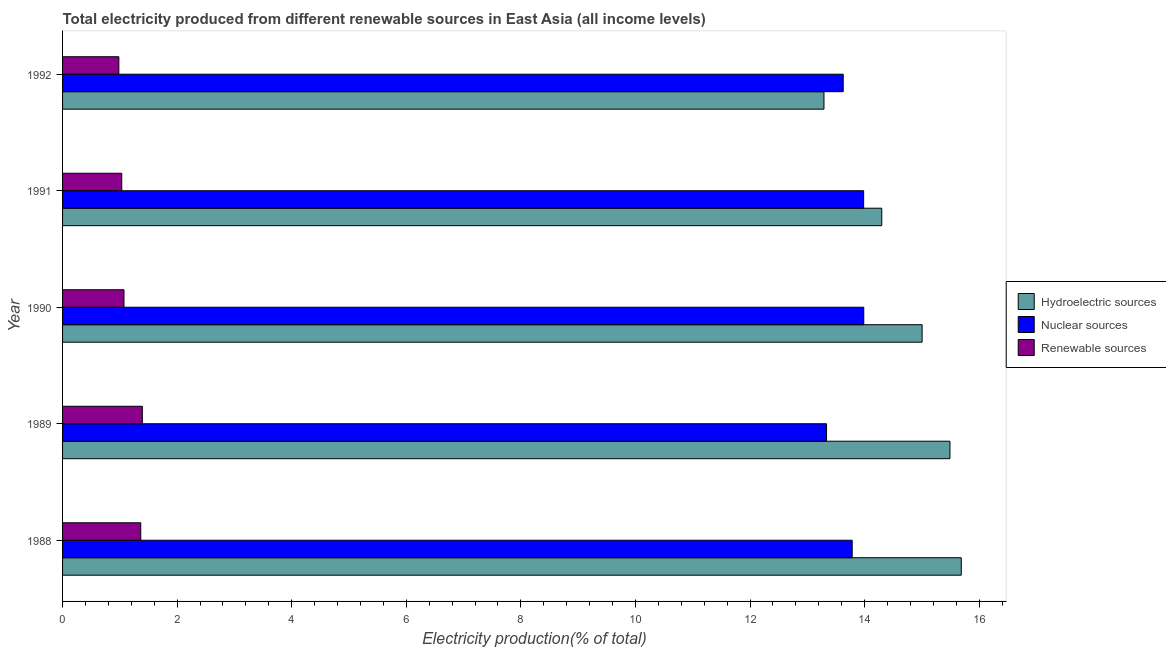How many groups of bars are there?
Make the answer very short. 5. Are the number of bars on each tick of the Y-axis equal?
Provide a short and direct response. Yes. What is the label of the 1st group of bars from the top?
Offer a terse response. 1992. In how many cases, is the number of bars for a given year not equal to the number of legend labels?
Your answer should be very brief. 0. What is the percentage of electricity produced by hydroelectric sources in 1992?
Your response must be concise. 13.29. Across all years, what is the maximum percentage of electricity produced by renewable sources?
Your response must be concise. 1.39. Across all years, what is the minimum percentage of electricity produced by nuclear sources?
Your answer should be very brief. 13.34. In which year was the percentage of electricity produced by nuclear sources maximum?
Make the answer very short. 1990. What is the total percentage of electricity produced by renewable sources in the graph?
Keep it short and to the point. 5.84. What is the difference between the percentage of electricity produced by renewable sources in 1989 and that in 1990?
Your answer should be compact. 0.32. What is the difference between the percentage of electricity produced by renewable sources in 1991 and the percentage of electricity produced by hydroelectric sources in 1989?
Your answer should be compact. -14.46. What is the average percentage of electricity produced by renewable sources per year?
Keep it short and to the point. 1.17. In the year 1992, what is the difference between the percentage of electricity produced by nuclear sources and percentage of electricity produced by hydroelectric sources?
Make the answer very short. 0.34. In how many years, is the percentage of electricity produced by nuclear sources greater than 6.4 %?
Keep it short and to the point. 5. What is the ratio of the percentage of electricity produced by hydroelectric sources in 1988 to that in 1991?
Keep it short and to the point. 1.1. Is the difference between the percentage of electricity produced by renewable sources in 1988 and 1992 greater than the difference between the percentage of electricity produced by hydroelectric sources in 1988 and 1992?
Provide a succinct answer. No. What is the difference between the highest and the second highest percentage of electricity produced by nuclear sources?
Ensure brevity in your answer.  0. What is the difference between the highest and the lowest percentage of electricity produced by hydroelectric sources?
Ensure brevity in your answer.  2.4. Is the sum of the percentage of electricity produced by renewable sources in 1989 and 1991 greater than the maximum percentage of electricity produced by hydroelectric sources across all years?
Ensure brevity in your answer.  No. What does the 1st bar from the top in 1988 represents?
Give a very brief answer. Renewable sources. What does the 2nd bar from the bottom in 1990 represents?
Ensure brevity in your answer.  Nuclear sources. Is it the case that in every year, the sum of the percentage of electricity produced by hydroelectric sources and percentage of electricity produced by nuclear sources is greater than the percentage of electricity produced by renewable sources?
Provide a succinct answer. Yes. How many bars are there?
Your response must be concise. 15. How many years are there in the graph?
Keep it short and to the point. 5. Are the values on the major ticks of X-axis written in scientific E-notation?
Provide a short and direct response. No. Where does the legend appear in the graph?
Your answer should be very brief. Center right. How are the legend labels stacked?
Your answer should be compact. Vertical. What is the title of the graph?
Your answer should be very brief. Total electricity produced from different renewable sources in East Asia (all income levels). What is the label or title of the X-axis?
Make the answer very short. Electricity production(% of total). What is the label or title of the Y-axis?
Your response must be concise. Year. What is the Electricity production(% of total) of Hydroelectric sources in 1988?
Offer a terse response. 15.69. What is the Electricity production(% of total) in Nuclear sources in 1988?
Give a very brief answer. 13.78. What is the Electricity production(% of total) in Renewable sources in 1988?
Your response must be concise. 1.36. What is the Electricity production(% of total) of Hydroelectric sources in 1989?
Make the answer very short. 15.49. What is the Electricity production(% of total) of Nuclear sources in 1989?
Provide a succinct answer. 13.34. What is the Electricity production(% of total) of Renewable sources in 1989?
Provide a short and direct response. 1.39. What is the Electricity production(% of total) of Hydroelectric sources in 1990?
Make the answer very short. 15. What is the Electricity production(% of total) of Nuclear sources in 1990?
Your response must be concise. 13.99. What is the Electricity production(% of total) in Renewable sources in 1990?
Your answer should be compact. 1.07. What is the Electricity production(% of total) in Hydroelectric sources in 1991?
Make the answer very short. 14.3. What is the Electricity production(% of total) in Nuclear sources in 1991?
Your response must be concise. 13.98. What is the Electricity production(% of total) of Renewable sources in 1991?
Provide a succinct answer. 1.03. What is the Electricity production(% of total) of Hydroelectric sources in 1992?
Your response must be concise. 13.29. What is the Electricity production(% of total) in Nuclear sources in 1992?
Offer a terse response. 13.63. What is the Electricity production(% of total) of Renewable sources in 1992?
Your answer should be very brief. 0.98. Across all years, what is the maximum Electricity production(% of total) of Hydroelectric sources?
Your response must be concise. 15.69. Across all years, what is the maximum Electricity production(% of total) in Nuclear sources?
Offer a very short reply. 13.99. Across all years, what is the maximum Electricity production(% of total) of Renewable sources?
Your response must be concise. 1.39. Across all years, what is the minimum Electricity production(% of total) of Hydroelectric sources?
Keep it short and to the point. 13.29. Across all years, what is the minimum Electricity production(% of total) in Nuclear sources?
Provide a short and direct response. 13.34. Across all years, what is the minimum Electricity production(% of total) in Renewable sources?
Provide a short and direct response. 0.98. What is the total Electricity production(% of total) of Hydroelectric sources in the graph?
Give a very brief answer. 73.77. What is the total Electricity production(% of total) in Nuclear sources in the graph?
Give a very brief answer. 68.71. What is the total Electricity production(% of total) in Renewable sources in the graph?
Your response must be concise. 5.84. What is the difference between the Electricity production(% of total) of Hydroelectric sources in 1988 and that in 1989?
Give a very brief answer. 0.2. What is the difference between the Electricity production(% of total) in Nuclear sources in 1988 and that in 1989?
Offer a terse response. 0.45. What is the difference between the Electricity production(% of total) of Renewable sources in 1988 and that in 1989?
Make the answer very short. -0.03. What is the difference between the Electricity production(% of total) of Hydroelectric sources in 1988 and that in 1990?
Your answer should be compact. 0.68. What is the difference between the Electricity production(% of total) in Nuclear sources in 1988 and that in 1990?
Offer a very short reply. -0.2. What is the difference between the Electricity production(% of total) of Renewable sources in 1988 and that in 1990?
Your answer should be very brief. 0.29. What is the difference between the Electricity production(% of total) in Hydroelectric sources in 1988 and that in 1991?
Make the answer very short. 1.39. What is the difference between the Electricity production(% of total) of Nuclear sources in 1988 and that in 1991?
Offer a very short reply. -0.2. What is the difference between the Electricity production(% of total) of Renewable sources in 1988 and that in 1991?
Your answer should be very brief. 0.33. What is the difference between the Electricity production(% of total) of Hydroelectric sources in 1988 and that in 1992?
Ensure brevity in your answer.  2.4. What is the difference between the Electricity production(% of total) of Nuclear sources in 1988 and that in 1992?
Provide a succinct answer. 0.16. What is the difference between the Electricity production(% of total) of Renewable sources in 1988 and that in 1992?
Provide a short and direct response. 0.38. What is the difference between the Electricity production(% of total) of Hydroelectric sources in 1989 and that in 1990?
Ensure brevity in your answer.  0.49. What is the difference between the Electricity production(% of total) in Nuclear sources in 1989 and that in 1990?
Give a very brief answer. -0.65. What is the difference between the Electricity production(% of total) of Renewable sources in 1989 and that in 1990?
Give a very brief answer. 0.32. What is the difference between the Electricity production(% of total) in Hydroelectric sources in 1989 and that in 1991?
Offer a very short reply. 1.19. What is the difference between the Electricity production(% of total) in Nuclear sources in 1989 and that in 1991?
Make the answer very short. -0.65. What is the difference between the Electricity production(% of total) of Renewable sources in 1989 and that in 1991?
Your answer should be very brief. 0.36. What is the difference between the Electricity production(% of total) of Hydroelectric sources in 1989 and that in 1992?
Ensure brevity in your answer.  2.2. What is the difference between the Electricity production(% of total) of Nuclear sources in 1989 and that in 1992?
Your answer should be compact. -0.29. What is the difference between the Electricity production(% of total) of Renewable sources in 1989 and that in 1992?
Provide a short and direct response. 0.41. What is the difference between the Electricity production(% of total) in Hydroelectric sources in 1990 and that in 1991?
Offer a very short reply. 0.7. What is the difference between the Electricity production(% of total) in Nuclear sources in 1990 and that in 1991?
Keep it short and to the point. 0. What is the difference between the Electricity production(% of total) of Renewable sources in 1990 and that in 1991?
Provide a succinct answer. 0.04. What is the difference between the Electricity production(% of total) in Hydroelectric sources in 1990 and that in 1992?
Give a very brief answer. 1.71. What is the difference between the Electricity production(% of total) in Nuclear sources in 1990 and that in 1992?
Ensure brevity in your answer.  0.36. What is the difference between the Electricity production(% of total) of Renewable sources in 1990 and that in 1992?
Give a very brief answer. 0.09. What is the difference between the Electricity production(% of total) of Hydroelectric sources in 1991 and that in 1992?
Offer a terse response. 1.01. What is the difference between the Electricity production(% of total) of Nuclear sources in 1991 and that in 1992?
Your answer should be compact. 0.36. What is the difference between the Electricity production(% of total) of Renewable sources in 1991 and that in 1992?
Keep it short and to the point. 0.05. What is the difference between the Electricity production(% of total) in Hydroelectric sources in 1988 and the Electricity production(% of total) in Nuclear sources in 1989?
Make the answer very short. 2.35. What is the difference between the Electricity production(% of total) in Hydroelectric sources in 1988 and the Electricity production(% of total) in Renewable sources in 1989?
Your answer should be compact. 14.29. What is the difference between the Electricity production(% of total) in Nuclear sources in 1988 and the Electricity production(% of total) in Renewable sources in 1989?
Provide a succinct answer. 12.39. What is the difference between the Electricity production(% of total) in Hydroelectric sources in 1988 and the Electricity production(% of total) in Nuclear sources in 1990?
Make the answer very short. 1.7. What is the difference between the Electricity production(% of total) of Hydroelectric sources in 1988 and the Electricity production(% of total) of Renewable sources in 1990?
Your answer should be compact. 14.61. What is the difference between the Electricity production(% of total) of Nuclear sources in 1988 and the Electricity production(% of total) of Renewable sources in 1990?
Offer a terse response. 12.71. What is the difference between the Electricity production(% of total) in Hydroelectric sources in 1988 and the Electricity production(% of total) in Nuclear sources in 1991?
Your answer should be very brief. 1.7. What is the difference between the Electricity production(% of total) of Hydroelectric sources in 1988 and the Electricity production(% of total) of Renewable sources in 1991?
Make the answer very short. 14.65. What is the difference between the Electricity production(% of total) of Nuclear sources in 1988 and the Electricity production(% of total) of Renewable sources in 1991?
Ensure brevity in your answer.  12.75. What is the difference between the Electricity production(% of total) in Hydroelectric sources in 1988 and the Electricity production(% of total) in Nuclear sources in 1992?
Keep it short and to the point. 2.06. What is the difference between the Electricity production(% of total) of Hydroelectric sources in 1988 and the Electricity production(% of total) of Renewable sources in 1992?
Keep it short and to the point. 14.7. What is the difference between the Electricity production(% of total) of Nuclear sources in 1988 and the Electricity production(% of total) of Renewable sources in 1992?
Offer a terse response. 12.8. What is the difference between the Electricity production(% of total) in Hydroelectric sources in 1989 and the Electricity production(% of total) in Nuclear sources in 1990?
Ensure brevity in your answer.  1.5. What is the difference between the Electricity production(% of total) in Hydroelectric sources in 1989 and the Electricity production(% of total) in Renewable sources in 1990?
Keep it short and to the point. 14.42. What is the difference between the Electricity production(% of total) of Nuclear sources in 1989 and the Electricity production(% of total) of Renewable sources in 1990?
Your answer should be compact. 12.26. What is the difference between the Electricity production(% of total) in Hydroelectric sources in 1989 and the Electricity production(% of total) in Nuclear sources in 1991?
Your response must be concise. 1.51. What is the difference between the Electricity production(% of total) in Hydroelectric sources in 1989 and the Electricity production(% of total) in Renewable sources in 1991?
Provide a succinct answer. 14.46. What is the difference between the Electricity production(% of total) of Nuclear sources in 1989 and the Electricity production(% of total) of Renewable sources in 1991?
Keep it short and to the point. 12.3. What is the difference between the Electricity production(% of total) of Hydroelectric sources in 1989 and the Electricity production(% of total) of Nuclear sources in 1992?
Your response must be concise. 1.86. What is the difference between the Electricity production(% of total) of Hydroelectric sources in 1989 and the Electricity production(% of total) of Renewable sources in 1992?
Ensure brevity in your answer.  14.51. What is the difference between the Electricity production(% of total) in Nuclear sources in 1989 and the Electricity production(% of total) in Renewable sources in 1992?
Your response must be concise. 12.35. What is the difference between the Electricity production(% of total) in Hydroelectric sources in 1990 and the Electricity production(% of total) in Nuclear sources in 1991?
Offer a terse response. 1.02. What is the difference between the Electricity production(% of total) in Hydroelectric sources in 1990 and the Electricity production(% of total) in Renewable sources in 1991?
Provide a short and direct response. 13.97. What is the difference between the Electricity production(% of total) in Nuclear sources in 1990 and the Electricity production(% of total) in Renewable sources in 1991?
Make the answer very short. 12.95. What is the difference between the Electricity production(% of total) in Hydroelectric sources in 1990 and the Electricity production(% of total) in Nuclear sources in 1992?
Provide a succinct answer. 1.38. What is the difference between the Electricity production(% of total) of Hydroelectric sources in 1990 and the Electricity production(% of total) of Renewable sources in 1992?
Keep it short and to the point. 14.02. What is the difference between the Electricity production(% of total) in Nuclear sources in 1990 and the Electricity production(% of total) in Renewable sources in 1992?
Your answer should be very brief. 13. What is the difference between the Electricity production(% of total) in Hydroelectric sources in 1991 and the Electricity production(% of total) in Nuclear sources in 1992?
Provide a succinct answer. 0.67. What is the difference between the Electricity production(% of total) of Hydroelectric sources in 1991 and the Electricity production(% of total) of Renewable sources in 1992?
Give a very brief answer. 13.32. What is the difference between the Electricity production(% of total) of Nuclear sources in 1991 and the Electricity production(% of total) of Renewable sources in 1992?
Your response must be concise. 13. What is the average Electricity production(% of total) in Hydroelectric sources per year?
Offer a terse response. 14.75. What is the average Electricity production(% of total) in Nuclear sources per year?
Make the answer very short. 13.74. What is the average Electricity production(% of total) in Renewable sources per year?
Your answer should be very brief. 1.17. In the year 1988, what is the difference between the Electricity production(% of total) in Hydroelectric sources and Electricity production(% of total) in Nuclear sources?
Your answer should be compact. 1.9. In the year 1988, what is the difference between the Electricity production(% of total) of Hydroelectric sources and Electricity production(% of total) of Renewable sources?
Ensure brevity in your answer.  14.32. In the year 1988, what is the difference between the Electricity production(% of total) of Nuclear sources and Electricity production(% of total) of Renewable sources?
Your answer should be compact. 12.42. In the year 1989, what is the difference between the Electricity production(% of total) of Hydroelectric sources and Electricity production(% of total) of Nuclear sources?
Offer a very short reply. 2.15. In the year 1989, what is the difference between the Electricity production(% of total) of Hydroelectric sources and Electricity production(% of total) of Renewable sources?
Provide a succinct answer. 14.1. In the year 1989, what is the difference between the Electricity production(% of total) in Nuclear sources and Electricity production(% of total) in Renewable sources?
Offer a very short reply. 11.94. In the year 1990, what is the difference between the Electricity production(% of total) of Hydroelectric sources and Electricity production(% of total) of Nuclear sources?
Give a very brief answer. 1.02. In the year 1990, what is the difference between the Electricity production(% of total) of Hydroelectric sources and Electricity production(% of total) of Renewable sources?
Ensure brevity in your answer.  13.93. In the year 1990, what is the difference between the Electricity production(% of total) in Nuclear sources and Electricity production(% of total) in Renewable sources?
Provide a short and direct response. 12.91. In the year 1991, what is the difference between the Electricity production(% of total) in Hydroelectric sources and Electricity production(% of total) in Nuclear sources?
Your response must be concise. 0.32. In the year 1991, what is the difference between the Electricity production(% of total) of Hydroelectric sources and Electricity production(% of total) of Renewable sources?
Keep it short and to the point. 13.27. In the year 1991, what is the difference between the Electricity production(% of total) in Nuclear sources and Electricity production(% of total) in Renewable sources?
Keep it short and to the point. 12.95. In the year 1992, what is the difference between the Electricity production(% of total) in Hydroelectric sources and Electricity production(% of total) in Nuclear sources?
Your answer should be very brief. -0.34. In the year 1992, what is the difference between the Electricity production(% of total) of Hydroelectric sources and Electricity production(% of total) of Renewable sources?
Provide a succinct answer. 12.31. In the year 1992, what is the difference between the Electricity production(% of total) of Nuclear sources and Electricity production(% of total) of Renewable sources?
Offer a very short reply. 12.64. What is the ratio of the Electricity production(% of total) of Hydroelectric sources in 1988 to that in 1989?
Make the answer very short. 1.01. What is the ratio of the Electricity production(% of total) in Nuclear sources in 1988 to that in 1989?
Make the answer very short. 1.03. What is the ratio of the Electricity production(% of total) in Renewable sources in 1988 to that in 1989?
Offer a terse response. 0.98. What is the ratio of the Electricity production(% of total) in Hydroelectric sources in 1988 to that in 1990?
Offer a very short reply. 1.05. What is the ratio of the Electricity production(% of total) of Nuclear sources in 1988 to that in 1990?
Provide a short and direct response. 0.99. What is the ratio of the Electricity production(% of total) in Renewable sources in 1988 to that in 1990?
Offer a terse response. 1.27. What is the ratio of the Electricity production(% of total) in Hydroelectric sources in 1988 to that in 1991?
Provide a succinct answer. 1.1. What is the ratio of the Electricity production(% of total) of Nuclear sources in 1988 to that in 1991?
Offer a terse response. 0.99. What is the ratio of the Electricity production(% of total) in Renewable sources in 1988 to that in 1991?
Your response must be concise. 1.32. What is the ratio of the Electricity production(% of total) in Hydroelectric sources in 1988 to that in 1992?
Provide a short and direct response. 1.18. What is the ratio of the Electricity production(% of total) of Nuclear sources in 1988 to that in 1992?
Offer a terse response. 1.01. What is the ratio of the Electricity production(% of total) of Renewable sources in 1988 to that in 1992?
Offer a very short reply. 1.39. What is the ratio of the Electricity production(% of total) of Hydroelectric sources in 1989 to that in 1990?
Make the answer very short. 1.03. What is the ratio of the Electricity production(% of total) of Nuclear sources in 1989 to that in 1990?
Give a very brief answer. 0.95. What is the ratio of the Electricity production(% of total) in Renewable sources in 1989 to that in 1990?
Keep it short and to the point. 1.3. What is the ratio of the Electricity production(% of total) in Nuclear sources in 1989 to that in 1991?
Provide a succinct answer. 0.95. What is the ratio of the Electricity production(% of total) in Renewable sources in 1989 to that in 1991?
Provide a succinct answer. 1.35. What is the ratio of the Electricity production(% of total) in Hydroelectric sources in 1989 to that in 1992?
Your answer should be very brief. 1.17. What is the ratio of the Electricity production(% of total) of Nuclear sources in 1989 to that in 1992?
Keep it short and to the point. 0.98. What is the ratio of the Electricity production(% of total) of Renewable sources in 1989 to that in 1992?
Your answer should be compact. 1.42. What is the ratio of the Electricity production(% of total) in Hydroelectric sources in 1990 to that in 1991?
Your answer should be very brief. 1.05. What is the ratio of the Electricity production(% of total) in Nuclear sources in 1990 to that in 1991?
Make the answer very short. 1. What is the ratio of the Electricity production(% of total) of Renewable sources in 1990 to that in 1991?
Keep it short and to the point. 1.04. What is the ratio of the Electricity production(% of total) of Hydroelectric sources in 1990 to that in 1992?
Your answer should be compact. 1.13. What is the ratio of the Electricity production(% of total) in Nuclear sources in 1990 to that in 1992?
Your answer should be compact. 1.03. What is the ratio of the Electricity production(% of total) in Renewable sources in 1990 to that in 1992?
Offer a very short reply. 1.09. What is the ratio of the Electricity production(% of total) in Hydroelectric sources in 1991 to that in 1992?
Make the answer very short. 1.08. What is the ratio of the Electricity production(% of total) of Nuclear sources in 1991 to that in 1992?
Offer a very short reply. 1.03. What is the ratio of the Electricity production(% of total) in Renewable sources in 1991 to that in 1992?
Provide a short and direct response. 1.05. What is the difference between the highest and the second highest Electricity production(% of total) of Hydroelectric sources?
Give a very brief answer. 0.2. What is the difference between the highest and the second highest Electricity production(% of total) in Nuclear sources?
Give a very brief answer. 0. What is the difference between the highest and the second highest Electricity production(% of total) of Renewable sources?
Your response must be concise. 0.03. What is the difference between the highest and the lowest Electricity production(% of total) in Hydroelectric sources?
Your response must be concise. 2.4. What is the difference between the highest and the lowest Electricity production(% of total) of Nuclear sources?
Offer a terse response. 0.65. What is the difference between the highest and the lowest Electricity production(% of total) in Renewable sources?
Provide a succinct answer. 0.41. 